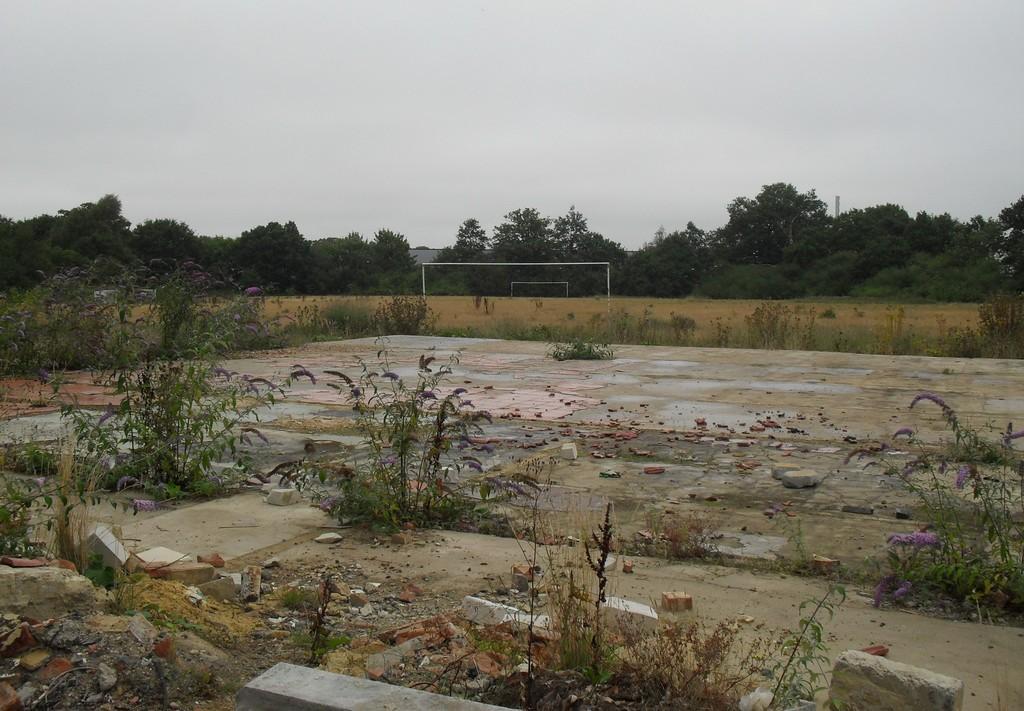Please provide a concise description of this image. In the picture we can see a land surface with some plants and some broken stones and far away from it, we can see a playground in the background we can see many trees and the sky. 